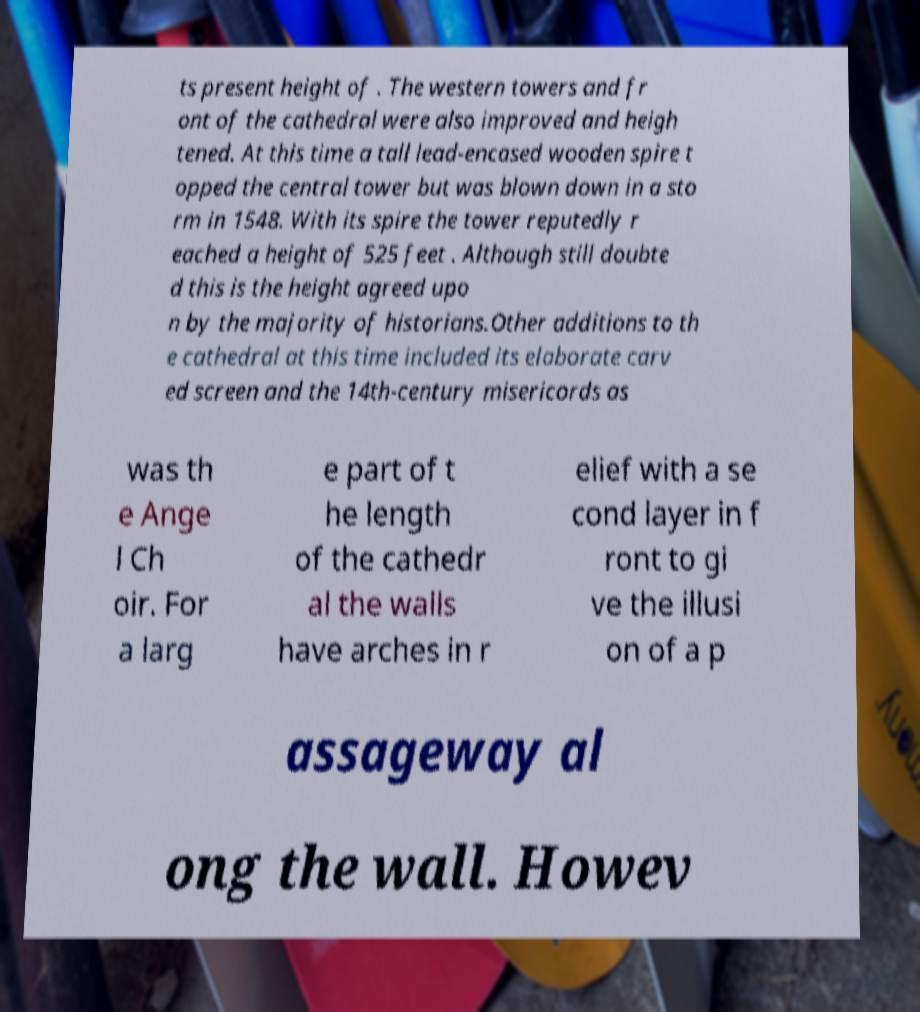Could you extract and type out the text from this image? ts present height of . The western towers and fr ont of the cathedral were also improved and heigh tened. At this time a tall lead-encased wooden spire t opped the central tower but was blown down in a sto rm in 1548. With its spire the tower reputedly r eached a height of 525 feet . Although still doubte d this is the height agreed upo n by the majority of historians.Other additions to th e cathedral at this time included its elaborate carv ed screen and the 14th-century misericords as was th e Ange l Ch oir. For a larg e part of t he length of the cathedr al the walls have arches in r elief with a se cond layer in f ront to gi ve the illusi on of a p assageway al ong the wall. Howev 